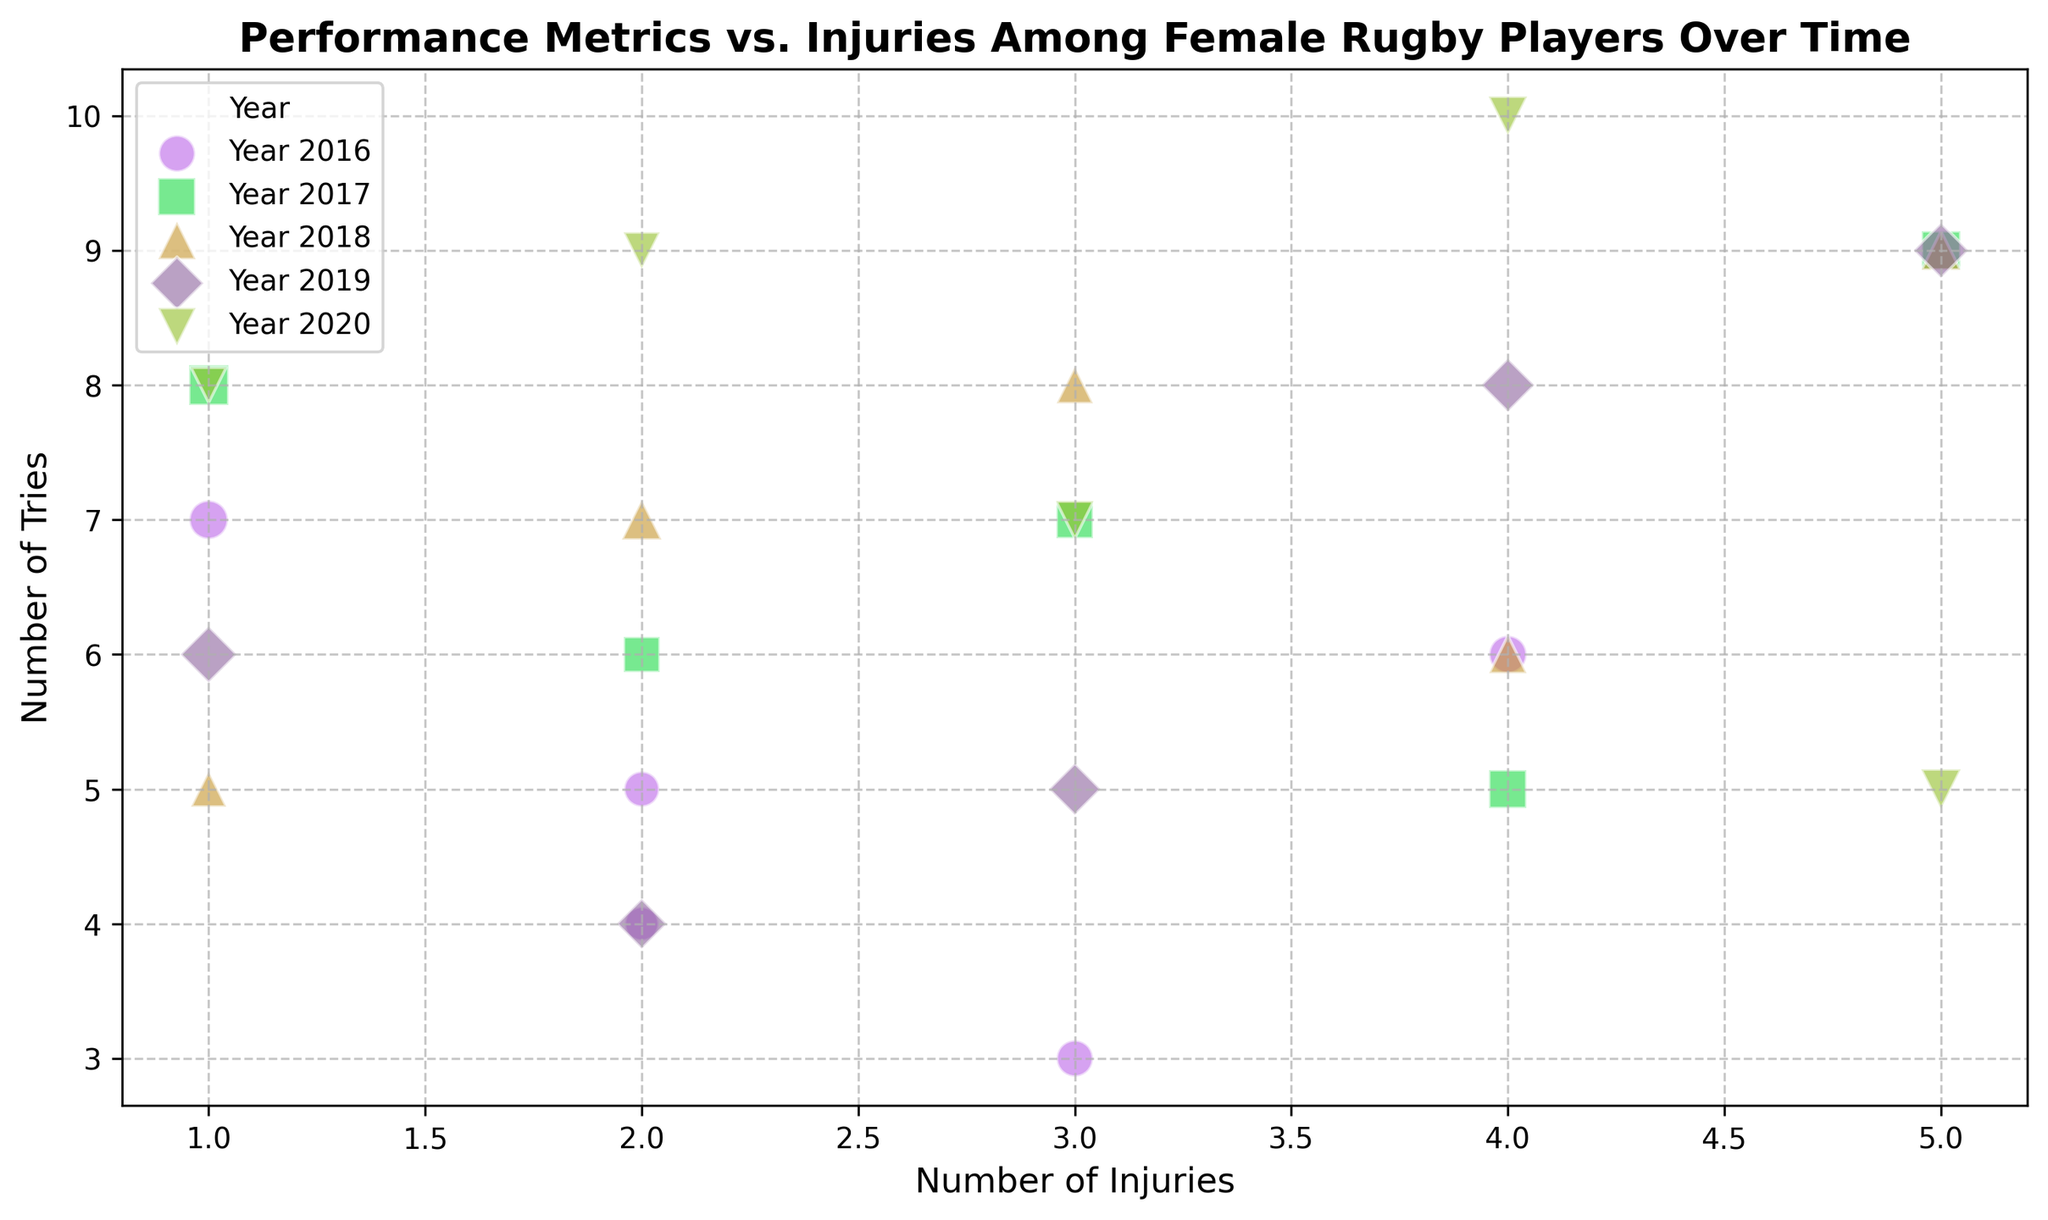What year had the player with the highest number of tries and what was their injury count? From the scatter plot, identify the data points with the highest number of tries and then look at their corresponding year and injury count.
Answer: 2020, 4 Which year had the lowest average number of injuries? Calculate the average number of injuries for each year by summing the injuries and dividing by the total number of players, then compare these averages to find the lowest one.
Answer: 2018 What is the relationship between games played and the size of the markers on the plot? Evaluate the plot and notice the size of the markers which is scaled by the number of games played by each player. Larger markers indicate more games played.
Answer: More games played, larger markers Between 2017 and 2019, which year had a player with injuries closest to the median number of injuries for those years combined? Calculate the median number of injuries for the combined years (2017, 2018, 2019) and identify which year from 2017 to 2019 has a data point closest to this median.
Answer: 2019 How does the distribution of tries compare across different years? Compare the spreads and clusters of the tries values for each year by looking at the different colored markers and their positions on the plot.
Answer: They vary but have overlapping ranges in most years Which marker color generally represents the year with most players having fewer injuries? Review the scatter plot and identify the color that corresponds to the year with many markers positioned on the lower part of the injuries axis.
Answer: Green (2018) In which year did a player with 5 injuries score their highest tries? Locate the markers representing 5 injuries across different years and then identify the year with the highest number of tries among those markers.
Answer: 2020 What is the general trend between the number of tries and injuries? Observe the overall pattern of the data points, looking for any discernible relationship between the number of tries and injuries.
Answer: No clear trend 